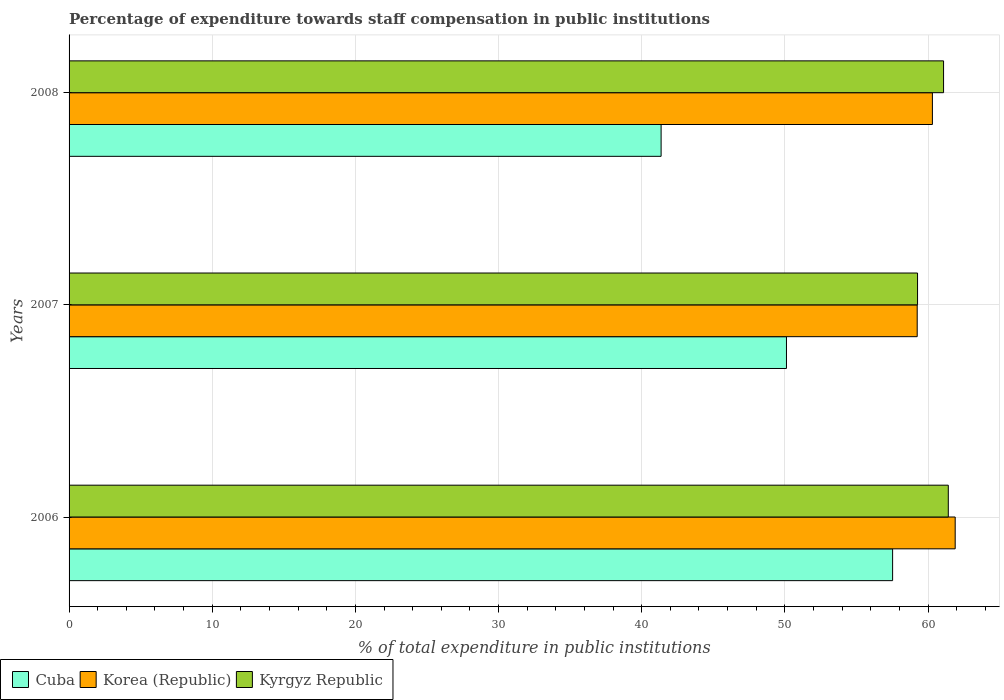How many different coloured bars are there?
Provide a succinct answer. 3. How many groups of bars are there?
Give a very brief answer. 3. Are the number of bars on each tick of the Y-axis equal?
Ensure brevity in your answer.  Yes. How many bars are there on the 2nd tick from the top?
Your answer should be very brief. 3. How many bars are there on the 2nd tick from the bottom?
Make the answer very short. 3. What is the label of the 2nd group of bars from the top?
Offer a terse response. 2007. In how many cases, is the number of bars for a given year not equal to the number of legend labels?
Ensure brevity in your answer.  0. What is the percentage of expenditure towards staff compensation in Kyrgyz Republic in 2008?
Provide a succinct answer. 61.09. Across all years, what is the maximum percentage of expenditure towards staff compensation in Kyrgyz Republic?
Provide a short and direct response. 61.42. Across all years, what is the minimum percentage of expenditure towards staff compensation in Korea (Republic)?
Give a very brief answer. 59.25. What is the total percentage of expenditure towards staff compensation in Korea (Republic) in the graph?
Keep it short and to the point. 181.45. What is the difference between the percentage of expenditure towards staff compensation in Cuba in 2006 and that in 2008?
Ensure brevity in your answer.  16.17. What is the difference between the percentage of expenditure towards staff compensation in Cuba in 2006 and the percentage of expenditure towards staff compensation in Kyrgyz Republic in 2007?
Provide a short and direct response. -1.74. What is the average percentage of expenditure towards staff compensation in Cuba per year?
Provide a short and direct response. 49.67. In the year 2008, what is the difference between the percentage of expenditure towards staff compensation in Korea (Republic) and percentage of expenditure towards staff compensation in Kyrgyz Republic?
Give a very brief answer. -0.78. In how many years, is the percentage of expenditure towards staff compensation in Korea (Republic) greater than 22 %?
Give a very brief answer. 3. What is the ratio of the percentage of expenditure towards staff compensation in Kyrgyz Republic in 2006 to that in 2007?
Make the answer very short. 1.04. Is the percentage of expenditure towards staff compensation in Cuba in 2007 less than that in 2008?
Your answer should be compact. No. Is the difference between the percentage of expenditure towards staff compensation in Korea (Republic) in 2007 and 2008 greater than the difference between the percentage of expenditure towards staff compensation in Kyrgyz Republic in 2007 and 2008?
Keep it short and to the point. Yes. What is the difference between the highest and the second highest percentage of expenditure towards staff compensation in Kyrgyz Republic?
Ensure brevity in your answer.  0.33. What is the difference between the highest and the lowest percentage of expenditure towards staff compensation in Kyrgyz Republic?
Your response must be concise. 2.15. What does the 1st bar from the top in 2006 represents?
Your answer should be compact. Kyrgyz Republic. What does the 1st bar from the bottom in 2007 represents?
Your answer should be compact. Cuba. Are all the bars in the graph horizontal?
Make the answer very short. Yes. What is the difference between two consecutive major ticks on the X-axis?
Provide a succinct answer. 10. Are the values on the major ticks of X-axis written in scientific E-notation?
Offer a very short reply. No. Does the graph contain any zero values?
Offer a very short reply. No. Does the graph contain grids?
Ensure brevity in your answer.  Yes. Where does the legend appear in the graph?
Keep it short and to the point. Bottom left. How many legend labels are there?
Offer a very short reply. 3. What is the title of the graph?
Your answer should be very brief. Percentage of expenditure towards staff compensation in public institutions. Does "Dominican Republic" appear as one of the legend labels in the graph?
Make the answer very short. No. What is the label or title of the X-axis?
Offer a terse response. % of total expenditure in public institutions. What is the label or title of the Y-axis?
Provide a succinct answer. Years. What is the % of total expenditure in public institutions in Cuba in 2006?
Ensure brevity in your answer.  57.53. What is the % of total expenditure in public institutions of Korea (Republic) in 2006?
Offer a very short reply. 61.9. What is the % of total expenditure in public institutions of Kyrgyz Republic in 2006?
Provide a short and direct response. 61.42. What is the % of total expenditure in public institutions in Cuba in 2007?
Your answer should be very brief. 50.11. What is the % of total expenditure in public institutions in Korea (Republic) in 2007?
Ensure brevity in your answer.  59.25. What is the % of total expenditure in public institutions of Kyrgyz Republic in 2007?
Your answer should be very brief. 59.27. What is the % of total expenditure in public institutions of Cuba in 2008?
Your answer should be compact. 41.36. What is the % of total expenditure in public institutions of Korea (Republic) in 2008?
Offer a very short reply. 60.31. What is the % of total expenditure in public institutions of Kyrgyz Republic in 2008?
Provide a succinct answer. 61.09. Across all years, what is the maximum % of total expenditure in public institutions in Cuba?
Your answer should be very brief. 57.53. Across all years, what is the maximum % of total expenditure in public institutions in Korea (Republic)?
Ensure brevity in your answer.  61.9. Across all years, what is the maximum % of total expenditure in public institutions in Kyrgyz Republic?
Provide a succinct answer. 61.42. Across all years, what is the minimum % of total expenditure in public institutions of Cuba?
Provide a short and direct response. 41.36. Across all years, what is the minimum % of total expenditure in public institutions of Korea (Republic)?
Your answer should be compact. 59.25. Across all years, what is the minimum % of total expenditure in public institutions in Kyrgyz Republic?
Your response must be concise. 59.27. What is the total % of total expenditure in public institutions in Cuba in the graph?
Offer a terse response. 149. What is the total % of total expenditure in public institutions in Korea (Republic) in the graph?
Keep it short and to the point. 181.45. What is the total % of total expenditure in public institutions of Kyrgyz Republic in the graph?
Keep it short and to the point. 181.77. What is the difference between the % of total expenditure in public institutions of Cuba in 2006 and that in 2007?
Offer a very short reply. 7.41. What is the difference between the % of total expenditure in public institutions in Korea (Republic) in 2006 and that in 2007?
Keep it short and to the point. 2.65. What is the difference between the % of total expenditure in public institutions of Kyrgyz Republic in 2006 and that in 2007?
Give a very brief answer. 2.15. What is the difference between the % of total expenditure in public institutions in Cuba in 2006 and that in 2008?
Provide a succinct answer. 16.17. What is the difference between the % of total expenditure in public institutions of Korea (Republic) in 2006 and that in 2008?
Provide a short and direct response. 1.59. What is the difference between the % of total expenditure in public institutions in Kyrgyz Republic in 2006 and that in 2008?
Provide a succinct answer. 0.33. What is the difference between the % of total expenditure in public institutions of Cuba in 2007 and that in 2008?
Your answer should be very brief. 8.76. What is the difference between the % of total expenditure in public institutions of Korea (Republic) in 2007 and that in 2008?
Your answer should be very brief. -1.06. What is the difference between the % of total expenditure in public institutions of Kyrgyz Republic in 2007 and that in 2008?
Offer a very short reply. -1.82. What is the difference between the % of total expenditure in public institutions in Cuba in 2006 and the % of total expenditure in public institutions in Korea (Republic) in 2007?
Provide a short and direct response. -1.72. What is the difference between the % of total expenditure in public institutions of Cuba in 2006 and the % of total expenditure in public institutions of Kyrgyz Republic in 2007?
Provide a short and direct response. -1.74. What is the difference between the % of total expenditure in public institutions in Korea (Republic) in 2006 and the % of total expenditure in public institutions in Kyrgyz Republic in 2007?
Keep it short and to the point. 2.63. What is the difference between the % of total expenditure in public institutions in Cuba in 2006 and the % of total expenditure in public institutions in Korea (Republic) in 2008?
Ensure brevity in your answer.  -2.78. What is the difference between the % of total expenditure in public institutions of Cuba in 2006 and the % of total expenditure in public institutions of Kyrgyz Republic in 2008?
Offer a terse response. -3.56. What is the difference between the % of total expenditure in public institutions in Korea (Republic) in 2006 and the % of total expenditure in public institutions in Kyrgyz Republic in 2008?
Keep it short and to the point. 0.81. What is the difference between the % of total expenditure in public institutions in Cuba in 2007 and the % of total expenditure in public institutions in Korea (Republic) in 2008?
Offer a terse response. -10.19. What is the difference between the % of total expenditure in public institutions of Cuba in 2007 and the % of total expenditure in public institutions of Kyrgyz Republic in 2008?
Provide a short and direct response. -10.97. What is the difference between the % of total expenditure in public institutions of Korea (Republic) in 2007 and the % of total expenditure in public institutions of Kyrgyz Republic in 2008?
Offer a very short reply. -1.84. What is the average % of total expenditure in public institutions of Cuba per year?
Provide a short and direct response. 49.67. What is the average % of total expenditure in public institutions of Korea (Republic) per year?
Your answer should be very brief. 60.48. What is the average % of total expenditure in public institutions in Kyrgyz Republic per year?
Provide a short and direct response. 60.59. In the year 2006, what is the difference between the % of total expenditure in public institutions of Cuba and % of total expenditure in public institutions of Korea (Republic)?
Provide a succinct answer. -4.37. In the year 2006, what is the difference between the % of total expenditure in public institutions in Cuba and % of total expenditure in public institutions in Kyrgyz Republic?
Give a very brief answer. -3.89. In the year 2006, what is the difference between the % of total expenditure in public institutions in Korea (Republic) and % of total expenditure in public institutions in Kyrgyz Republic?
Offer a terse response. 0.48. In the year 2007, what is the difference between the % of total expenditure in public institutions of Cuba and % of total expenditure in public institutions of Korea (Republic)?
Ensure brevity in your answer.  -9.13. In the year 2007, what is the difference between the % of total expenditure in public institutions of Cuba and % of total expenditure in public institutions of Kyrgyz Republic?
Provide a short and direct response. -9.16. In the year 2007, what is the difference between the % of total expenditure in public institutions in Korea (Republic) and % of total expenditure in public institutions in Kyrgyz Republic?
Give a very brief answer. -0.02. In the year 2008, what is the difference between the % of total expenditure in public institutions of Cuba and % of total expenditure in public institutions of Korea (Republic)?
Provide a succinct answer. -18.95. In the year 2008, what is the difference between the % of total expenditure in public institutions of Cuba and % of total expenditure in public institutions of Kyrgyz Republic?
Make the answer very short. -19.73. In the year 2008, what is the difference between the % of total expenditure in public institutions of Korea (Republic) and % of total expenditure in public institutions of Kyrgyz Republic?
Provide a succinct answer. -0.78. What is the ratio of the % of total expenditure in public institutions in Cuba in 2006 to that in 2007?
Your answer should be compact. 1.15. What is the ratio of the % of total expenditure in public institutions in Korea (Republic) in 2006 to that in 2007?
Ensure brevity in your answer.  1.04. What is the ratio of the % of total expenditure in public institutions of Kyrgyz Republic in 2006 to that in 2007?
Keep it short and to the point. 1.04. What is the ratio of the % of total expenditure in public institutions in Cuba in 2006 to that in 2008?
Your answer should be compact. 1.39. What is the ratio of the % of total expenditure in public institutions of Korea (Republic) in 2006 to that in 2008?
Your answer should be very brief. 1.03. What is the ratio of the % of total expenditure in public institutions of Kyrgyz Republic in 2006 to that in 2008?
Your answer should be compact. 1.01. What is the ratio of the % of total expenditure in public institutions of Cuba in 2007 to that in 2008?
Ensure brevity in your answer.  1.21. What is the ratio of the % of total expenditure in public institutions of Korea (Republic) in 2007 to that in 2008?
Offer a very short reply. 0.98. What is the ratio of the % of total expenditure in public institutions of Kyrgyz Republic in 2007 to that in 2008?
Your response must be concise. 0.97. What is the difference between the highest and the second highest % of total expenditure in public institutions in Cuba?
Provide a short and direct response. 7.41. What is the difference between the highest and the second highest % of total expenditure in public institutions of Korea (Republic)?
Give a very brief answer. 1.59. What is the difference between the highest and the second highest % of total expenditure in public institutions in Kyrgyz Republic?
Provide a short and direct response. 0.33. What is the difference between the highest and the lowest % of total expenditure in public institutions in Cuba?
Ensure brevity in your answer.  16.17. What is the difference between the highest and the lowest % of total expenditure in public institutions of Korea (Republic)?
Offer a terse response. 2.65. What is the difference between the highest and the lowest % of total expenditure in public institutions of Kyrgyz Republic?
Ensure brevity in your answer.  2.15. 